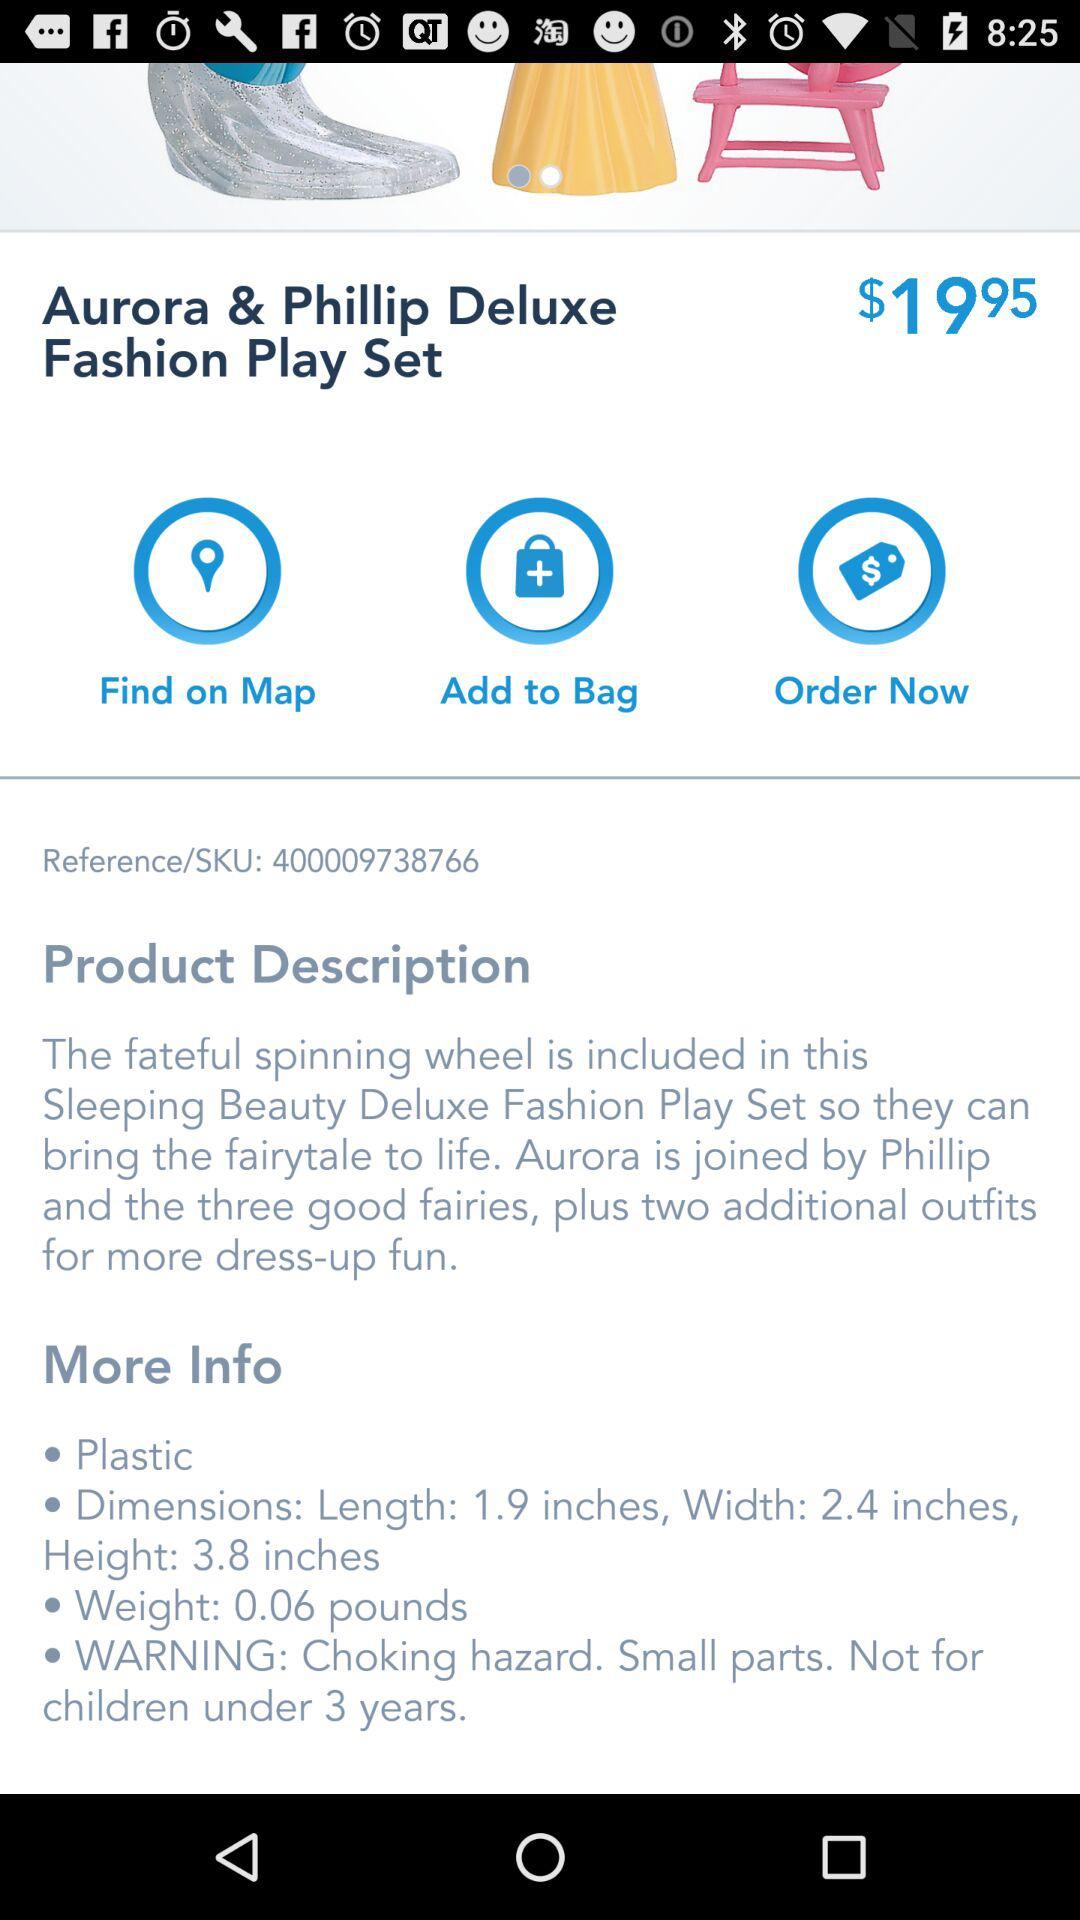What is the weight of the Aurora & Phillip Deluxe Fashion Play Set? The weight is 0.06 pounds. 